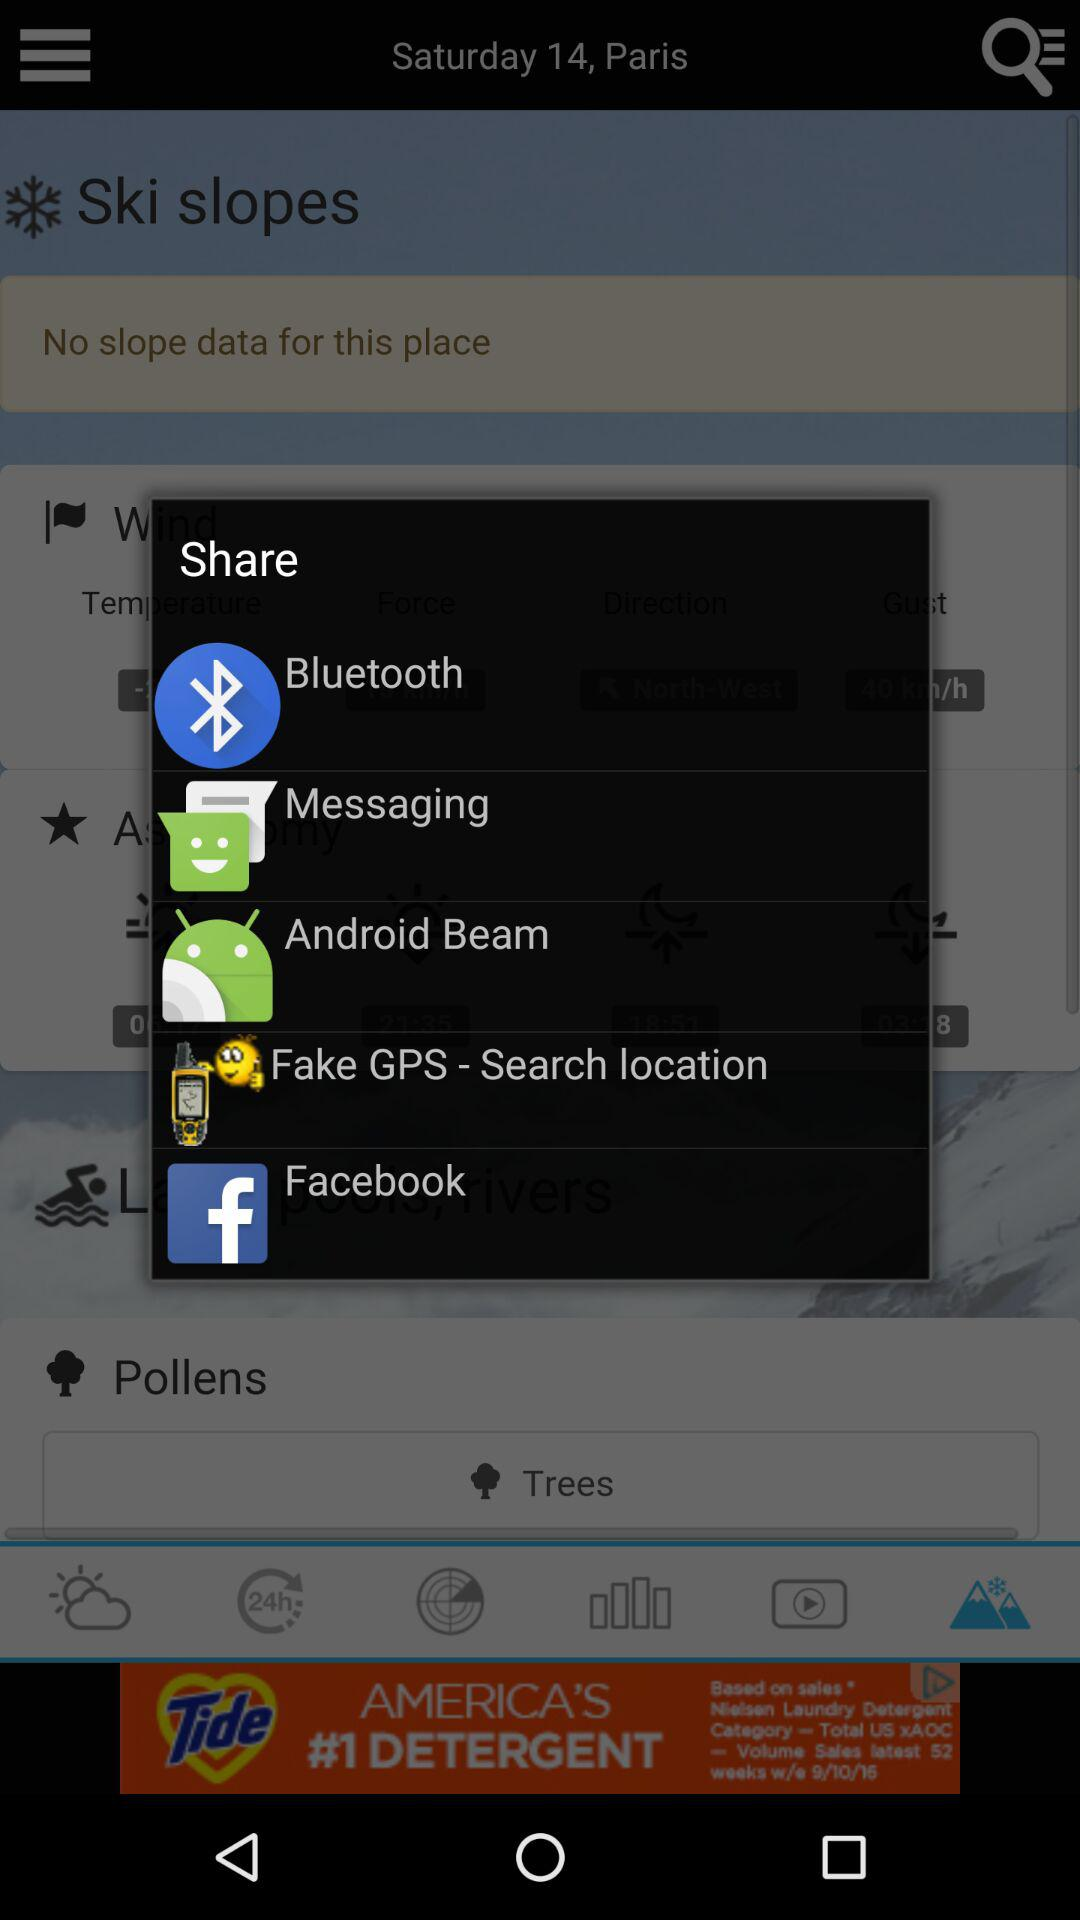How many items are in the share sheet?
Answer the question using a single word or phrase. 5 